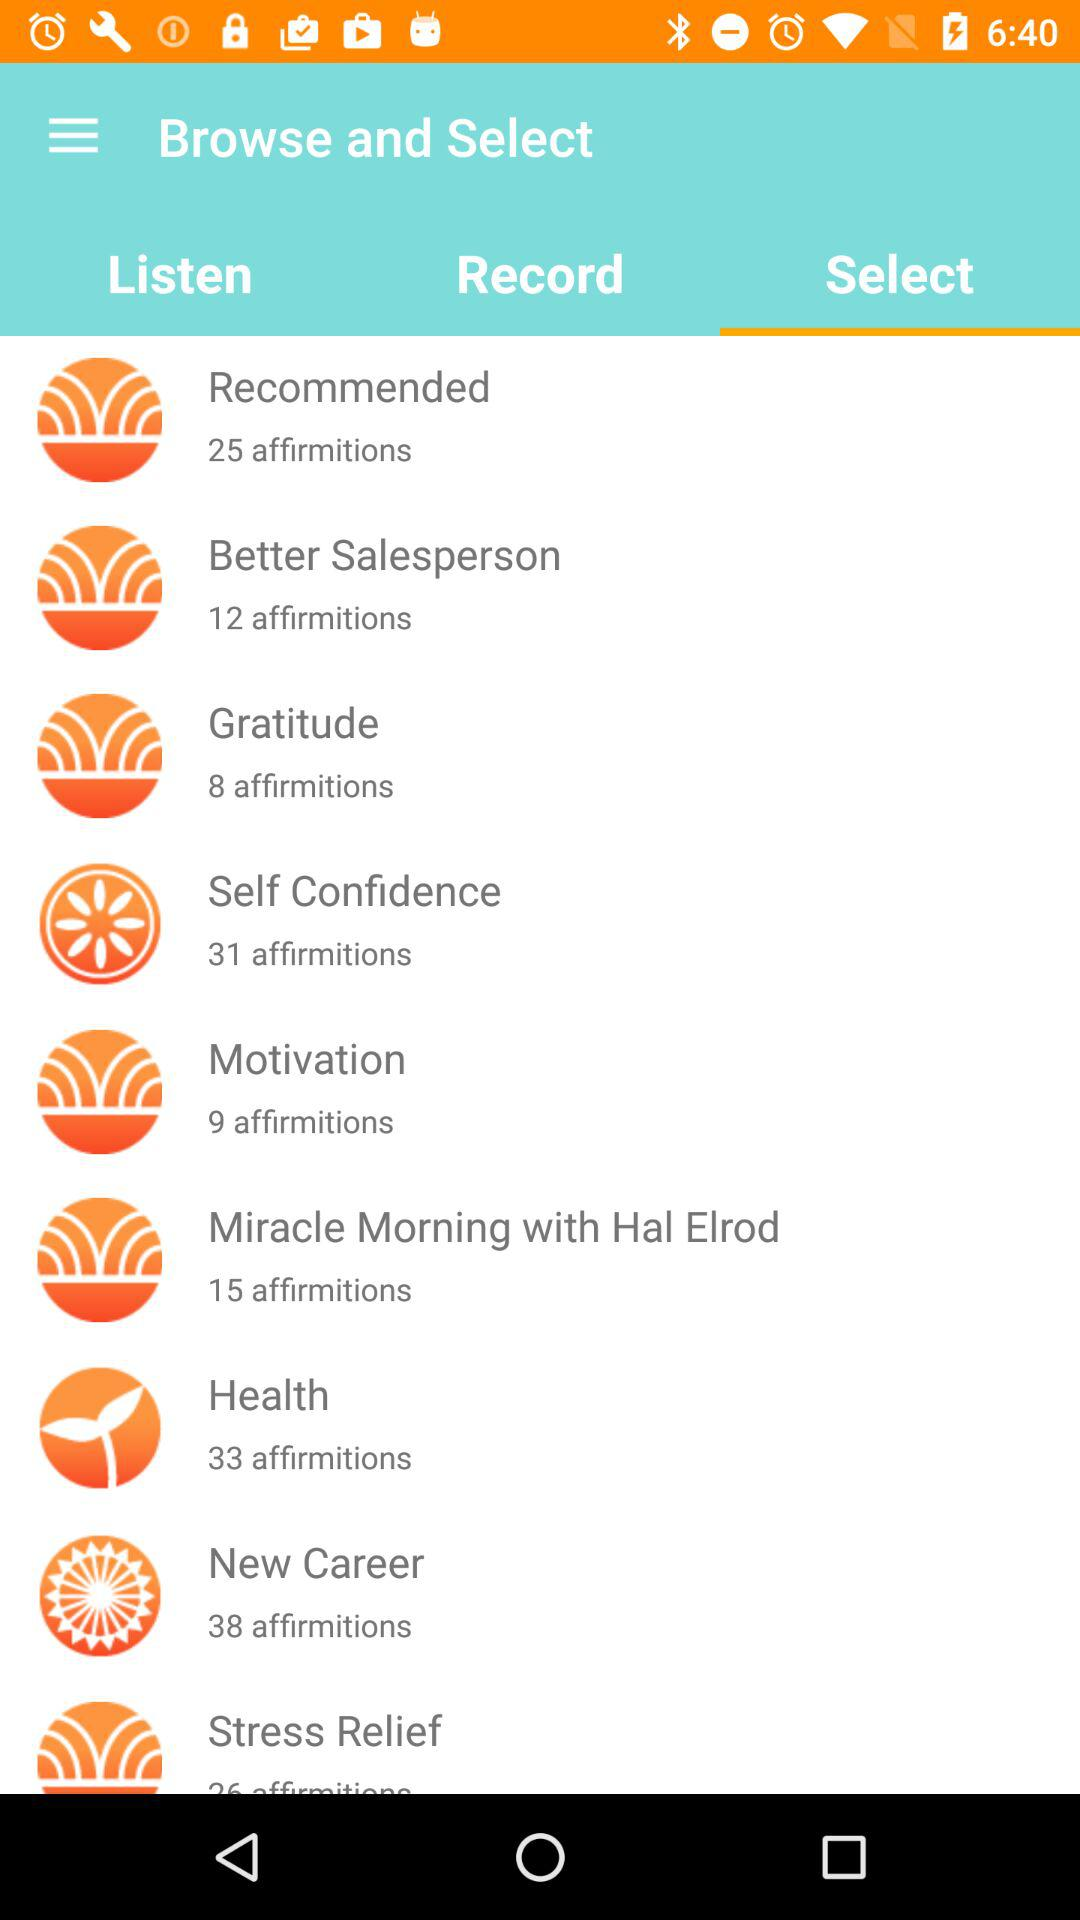How many affirmitions are there in "Health"? There are 33 affirmitions. 